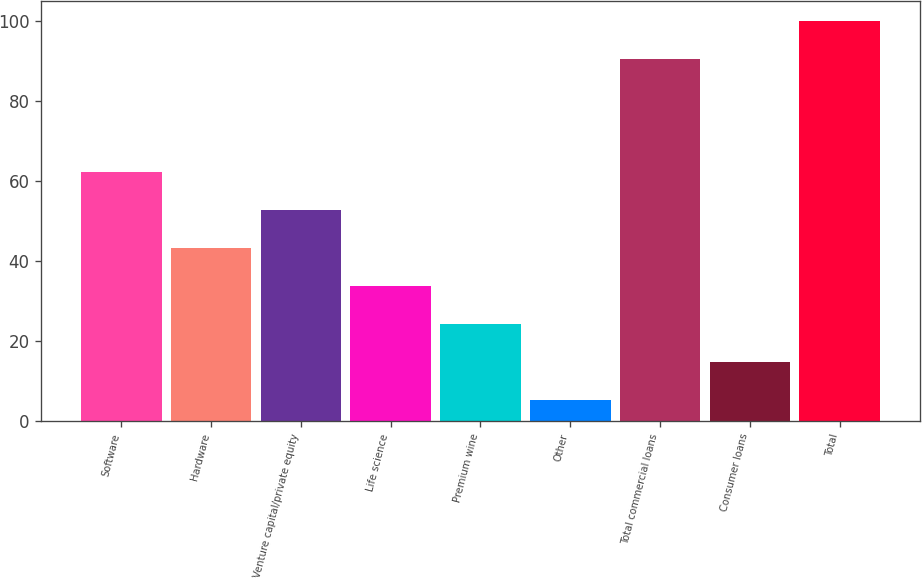Convert chart. <chart><loc_0><loc_0><loc_500><loc_500><bar_chart><fcel>Software<fcel>Hardware<fcel>Venture capital/private equity<fcel>Life science<fcel>Premium wine<fcel>Other<fcel>Total commercial loans<fcel>Consumer loans<fcel>Total<nl><fcel>62.12<fcel>43.18<fcel>52.65<fcel>33.71<fcel>24.24<fcel>5.3<fcel>90.4<fcel>14.77<fcel>100<nl></chart> 